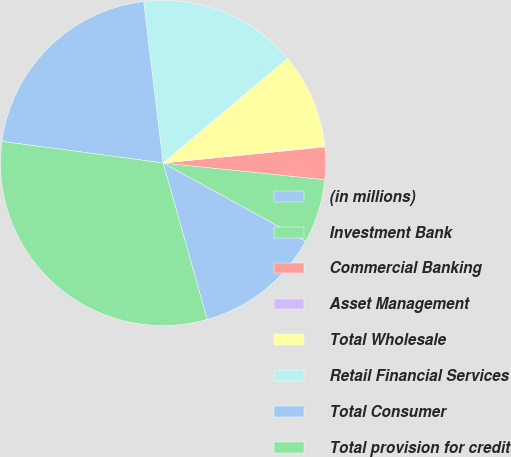Convert chart to OTSL. <chart><loc_0><loc_0><loc_500><loc_500><pie_chart><fcel>(in millions)<fcel>Investment Bank<fcel>Commercial Banking<fcel>Asset Management<fcel>Total Wholesale<fcel>Retail Financial Services<fcel>Total Consumer<fcel>Total provision for credit<nl><fcel>12.64%<fcel>6.35%<fcel>3.21%<fcel>0.07%<fcel>9.49%<fcel>15.78%<fcel>20.97%<fcel>31.49%<nl></chart> 